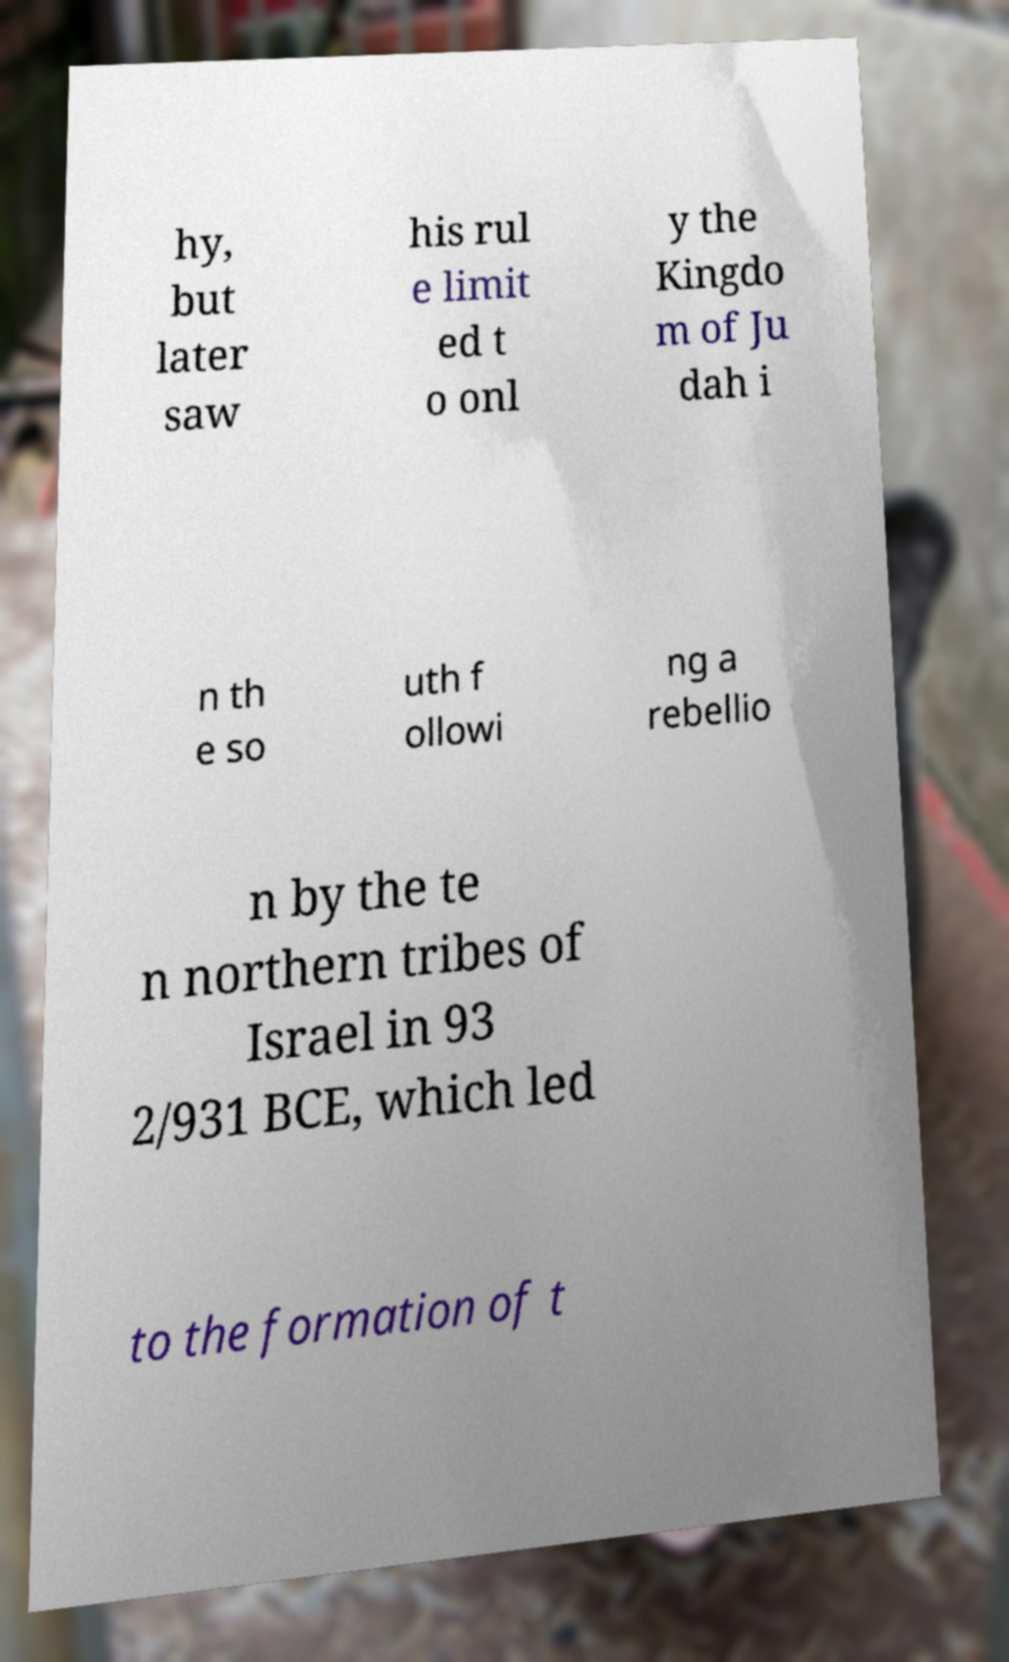Could you assist in decoding the text presented in this image and type it out clearly? hy, but later saw his rul e limit ed t o onl y the Kingdo m of Ju dah i n th e so uth f ollowi ng a rebellio n by the te n northern tribes of Israel in 93 2/931 BCE, which led to the formation of t 